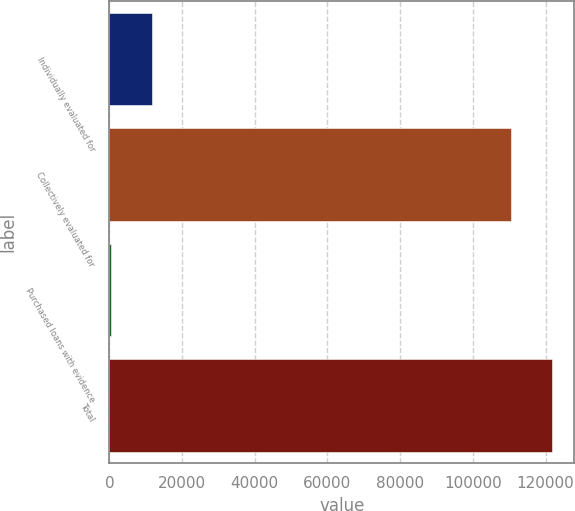<chart> <loc_0><loc_0><loc_500><loc_500><bar_chart><fcel>Individually evaluated for<fcel>Collectively evaluated for<fcel>Purchased loans with evidence<fcel>Total<nl><fcel>11778.1<fcel>110417<fcel>421<fcel>121774<nl></chart> 